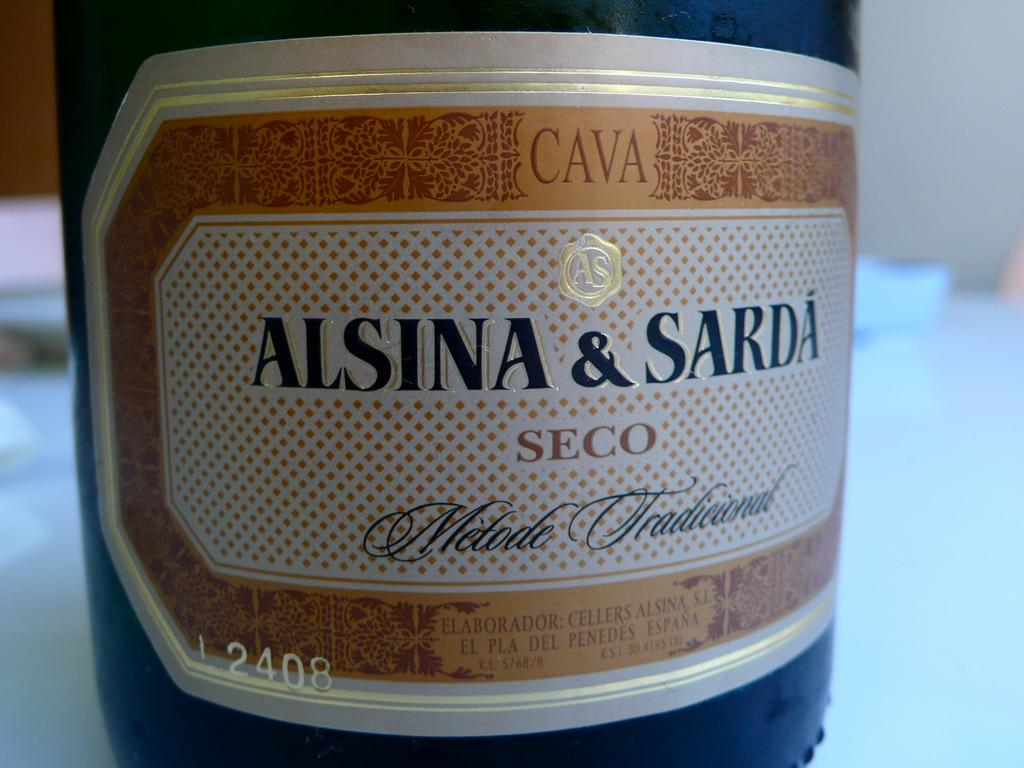<image>
Relay a brief, clear account of the picture shown. A close up of a dotted Alsina & Sarda Cava wine. 